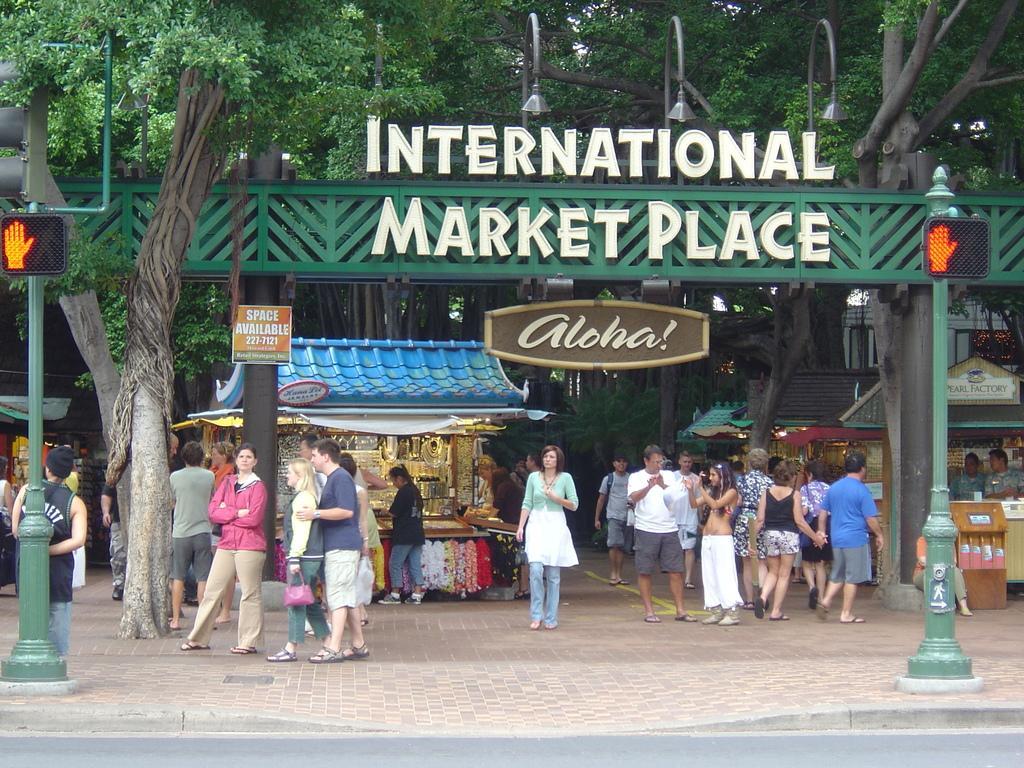Can you describe this image briefly? In the picture we can see a board near to the trees and on it we can see the International market place and near to it, we can see some people are standing and some are talking to each other and we can also some shop near the entrance and near to them we van see a path and beside it we can see a road. 